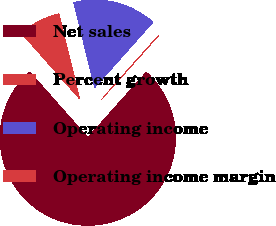<chart> <loc_0><loc_0><loc_500><loc_500><pie_chart><fcel>Net sales<fcel>Percent growth<fcel>Operating income<fcel>Operating income margin<nl><fcel>76.87%<fcel>0.03%<fcel>15.39%<fcel>7.71%<nl></chart> 